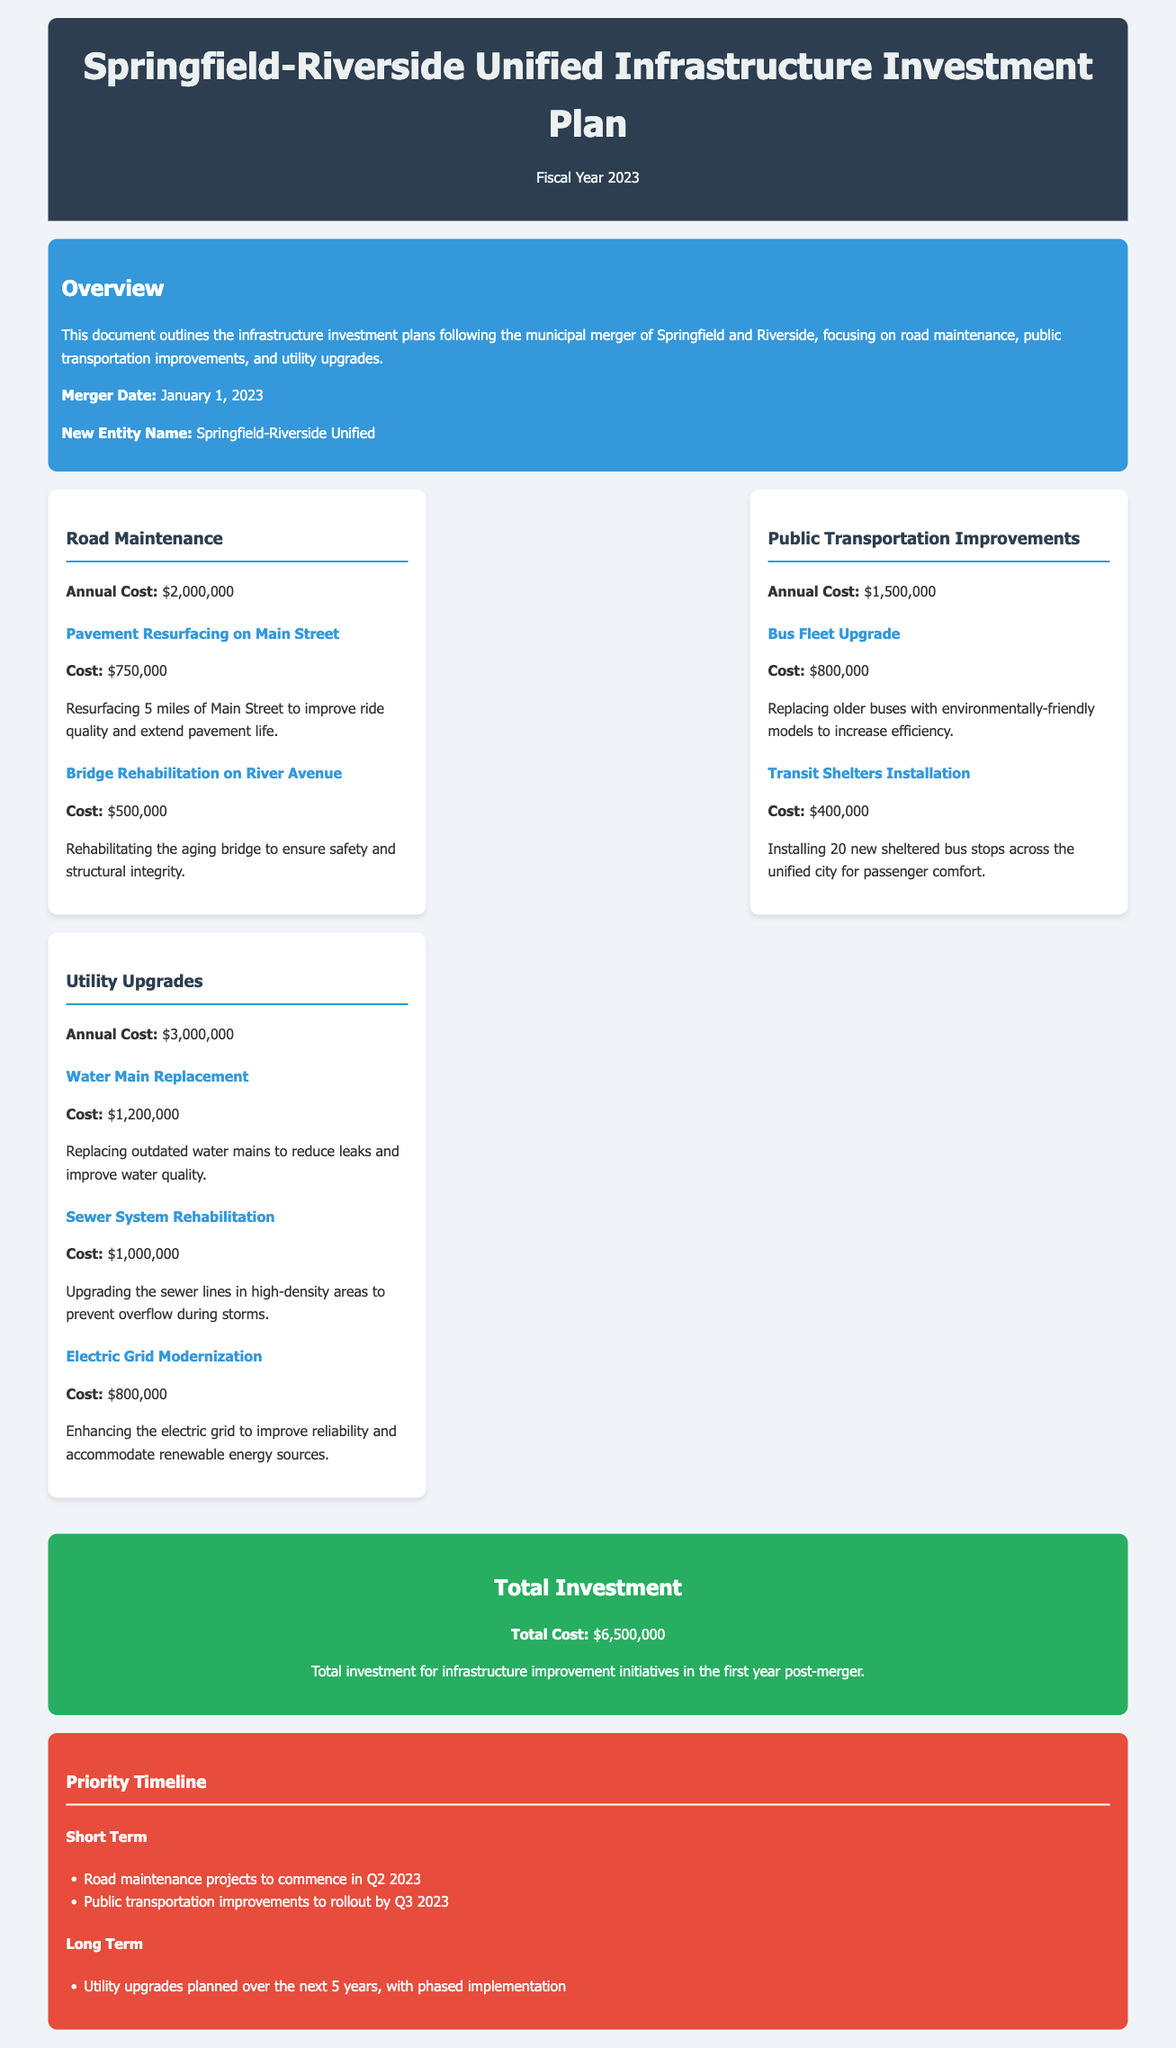What is the total investment for infrastructure? The total investment is explicitly stated in the document, which sums up the various infrastructure improvement initiatives.
Answer: $6,500,000 What is the annual cost of road maintenance? The annual cost of road maintenance is specified under that category in the cost breakdown section.
Answer: $2,000,000 What project has the highest cost in utility upgrades? The project with the highest cost can be found by comparing the costs listed under the utility upgrades category.
Answer: Water Main Replacement When is the planned rollout for public transportation improvements? The timeline indicates when public transportation improvements are expected to begin.
Answer: Q3 2023 How much is allocated for bus fleet upgrades? The amount specifically allocated for bus fleet upgrades is detailed under the public transportation improvements section.
Answer: $800,000 What is the cost for bridge rehabilitation on River Avenue? The document lists the cost for this specific project within the road maintenance category.
Answer: $500,000 What is the purpose of the water main replacement? The purpose is stated in the project details under utility upgrades.
Answer: Reduce leaks and improve water quality What is the annual cost for public transportation improvements? This figure is clearly stated in the cost breakdown section of the document.
Answer: $1,500,000 How many new transit shelters are planned for installation? The number of new transit shelters is mentioned in the description under public transportation improvements.
Answer: 20 